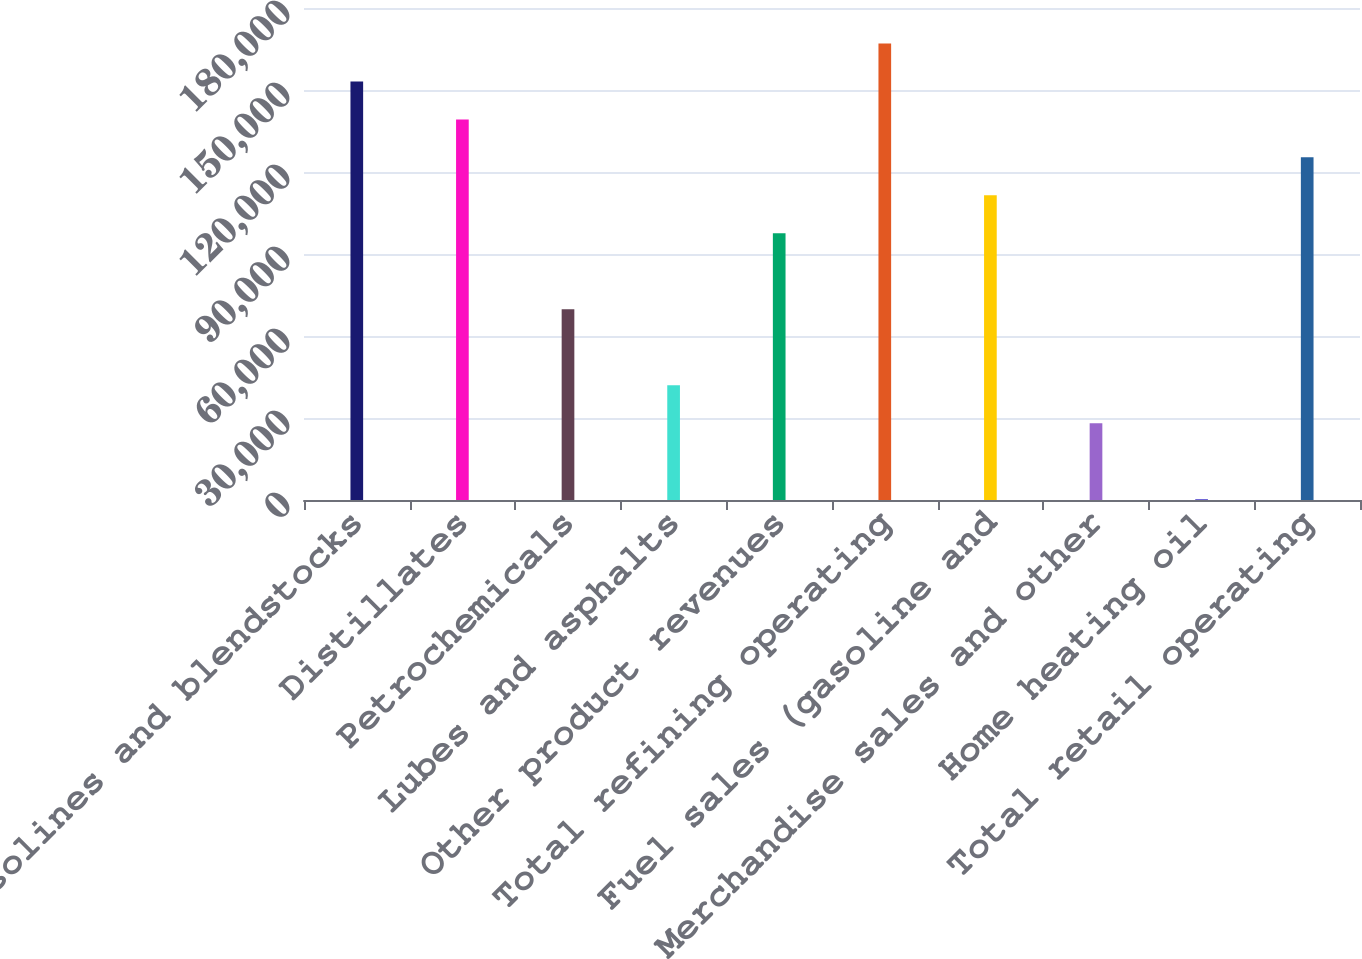Convert chart. <chart><loc_0><loc_0><loc_500><loc_500><bar_chart><fcel>Gasolines and blendstocks<fcel>Distillates<fcel>Petrochemicals<fcel>Lubes and asphalts<fcel>Other product revenues<fcel>Total refining operating<fcel>Fuel sales (gasoline and<fcel>Merchandise sales and other<fcel>Home heating oil<fcel>Total retail operating<nl><fcel>153144<fcel>139250<fcel>69782<fcel>41994.8<fcel>97569.2<fcel>167037<fcel>111463<fcel>28101.2<fcel>314<fcel>125356<nl></chart> 